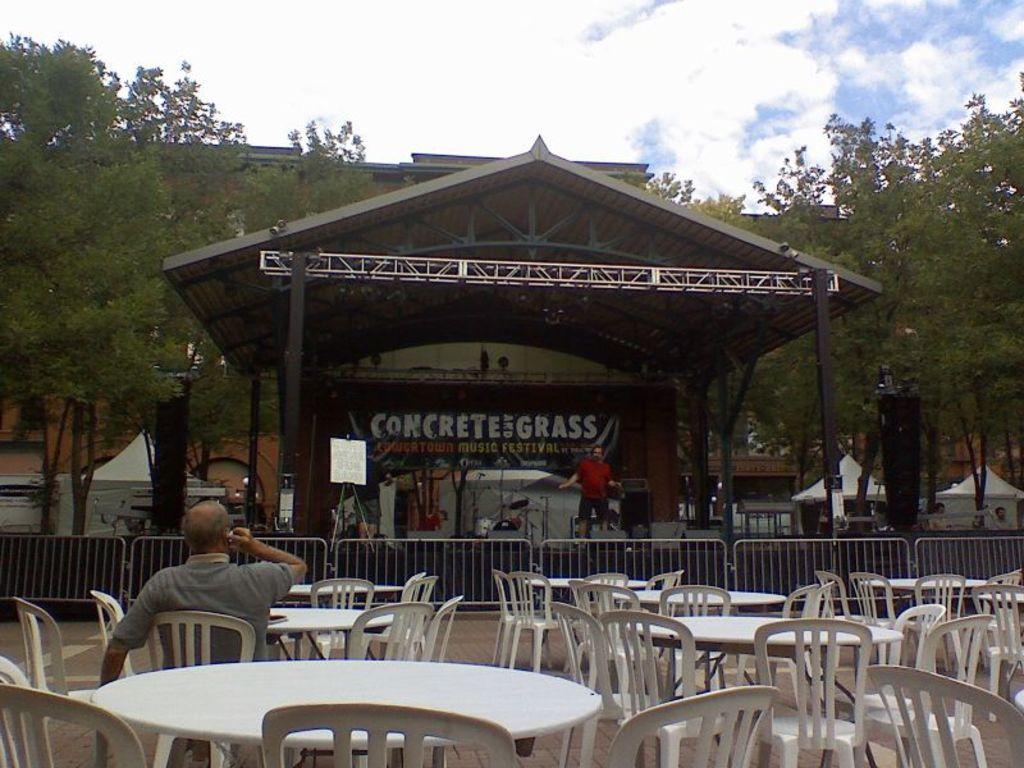Describe this image in one or two sentences. In this image we can see a table, and a man sitting on the chair, and in front a person is standing, and here is the building, and here are the trees, and at above the sky is cloudy. 